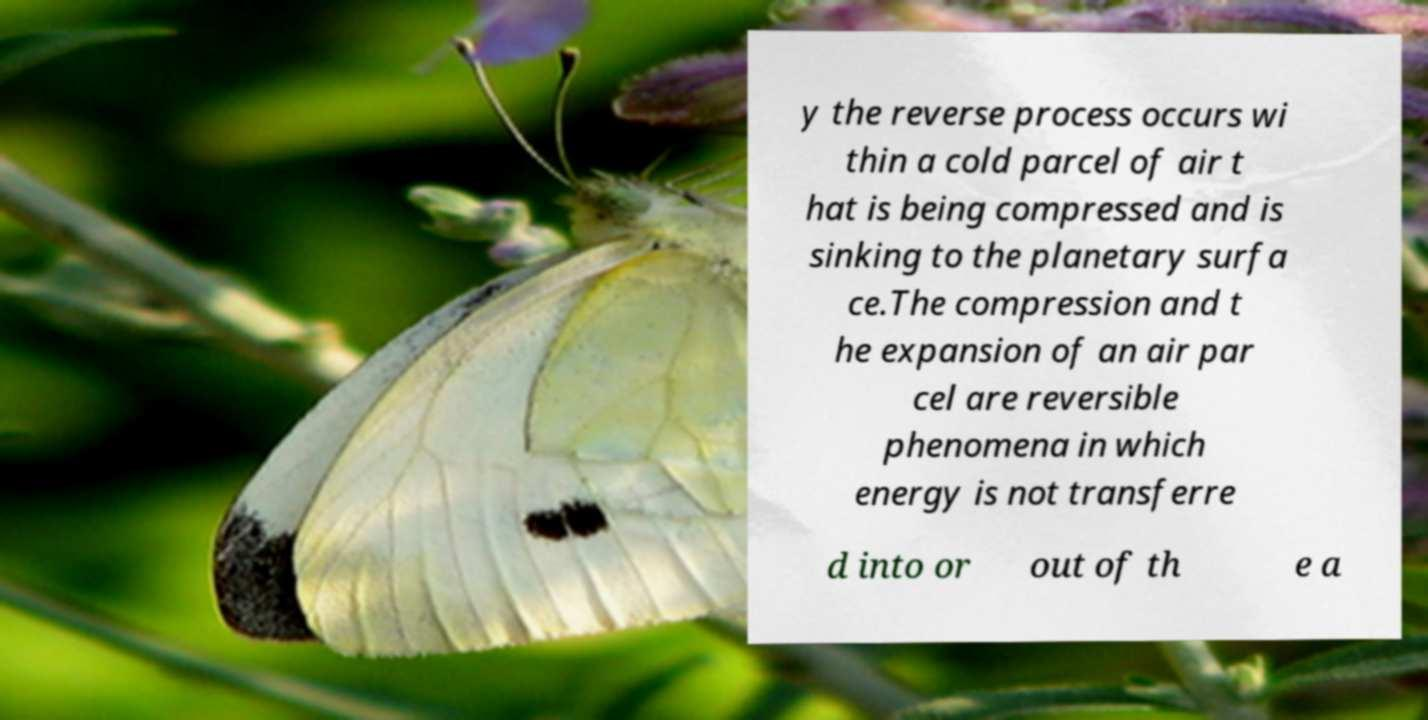Could you extract and type out the text from this image? y the reverse process occurs wi thin a cold parcel of air t hat is being compressed and is sinking to the planetary surfa ce.The compression and t he expansion of an air par cel are reversible phenomena in which energy is not transferre d into or out of th e a 